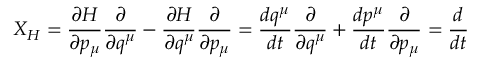<formula> <loc_0><loc_0><loc_500><loc_500>X _ { H } = { \frac { \partial H } { \partial p _ { \mu } } } { \frac { \partial } { \partial q ^ { \mu } } } - { \frac { \partial H } { \partial q ^ { \mu } } } { \frac { \partial } { \partial p _ { \mu } } } = { \frac { d q ^ { \mu } } { d t } } { \frac { \partial } { \partial q ^ { \mu } } } + { \frac { d p ^ { \mu } } { d t } } { \frac { \partial } { \partial p _ { \mu } } } = { \frac { d } { d t } }</formula> 